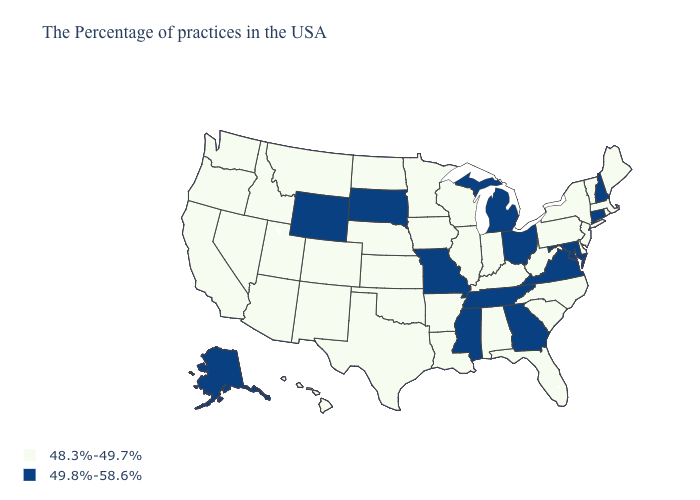Name the states that have a value in the range 48.3%-49.7%?
Give a very brief answer. Maine, Massachusetts, Rhode Island, Vermont, New York, New Jersey, Delaware, Pennsylvania, North Carolina, South Carolina, West Virginia, Florida, Kentucky, Indiana, Alabama, Wisconsin, Illinois, Louisiana, Arkansas, Minnesota, Iowa, Kansas, Nebraska, Oklahoma, Texas, North Dakota, Colorado, New Mexico, Utah, Montana, Arizona, Idaho, Nevada, California, Washington, Oregon, Hawaii. Which states hav the highest value in the South?
Concise answer only. Maryland, Virginia, Georgia, Tennessee, Mississippi. What is the lowest value in the USA?
Write a very short answer. 48.3%-49.7%. Name the states that have a value in the range 49.8%-58.6%?
Keep it brief. New Hampshire, Connecticut, Maryland, Virginia, Ohio, Georgia, Michigan, Tennessee, Mississippi, Missouri, South Dakota, Wyoming, Alaska. Name the states that have a value in the range 48.3%-49.7%?
Write a very short answer. Maine, Massachusetts, Rhode Island, Vermont, New York, New Jersey, Delaware, Pennsylvania, North Carolina, South Carolina, West Virginia, Florida, Kentucky, Indiana, Alabama, Wisconsin, Illinois, Louisiana, Arkansas, Minnesota, Iowa, Kansas, Nebraska, Oklahoma, Texas, North Dakota, Colorado, New Mexico, Utah, Montana, Arizona, Idaho, Nevada, California, Washington, Oregon, Hawaii. What is the highest value in states that border Missouri?
Concise answer only. 49.8%-58.6%. What is the value of Idaho?
Short answer required. 48.3%-49.7%. Name the states that have a value in the range 49.8%-58.6%?
Quick response, please. New Hampshire, Connecticut, Maryland, Virginia, Ohio, Georgia, Michigan, Tennessee, Mississippi, Missouri, South Dakota, Wyoming, Alaska. Name the states that have a value in the range 48.3%-49.7%?
Concise answer only. Maine, Massachusetts, Rhode Island, Vermont, New York, New Jersey, Delaware, Pennsylvania, North Carolina, South Carolina, West Virginia, Florida, Kentucky, Indiana, Alabama, Wisconsin, Illinois, Louisiana, Arkansas, Minnesota, Iowa, Kansas, Nebraska, Oklahoma, Texas, North Dakota, Colorado, New Mexico, Utah, Montana, Arizona, Idaho, Nevada, California, Washington, Oregon, Hawaii. Among the states that border Delaware , does Maryland have the highest value?
Give a very brief answer. Yes. What is the value of Kansas?
Concise answer only. 48.3%-49.7%. What is the value of Colorado?
Short answer required. 48.3%-49.7%. What is the lowest value in the USA?
Quick response, please. 48.3%-49.7%. How many symbols are there in the legend?
Answer briefly. 2. Is the legend a continuous bar?
Give a very brief answer. No. 